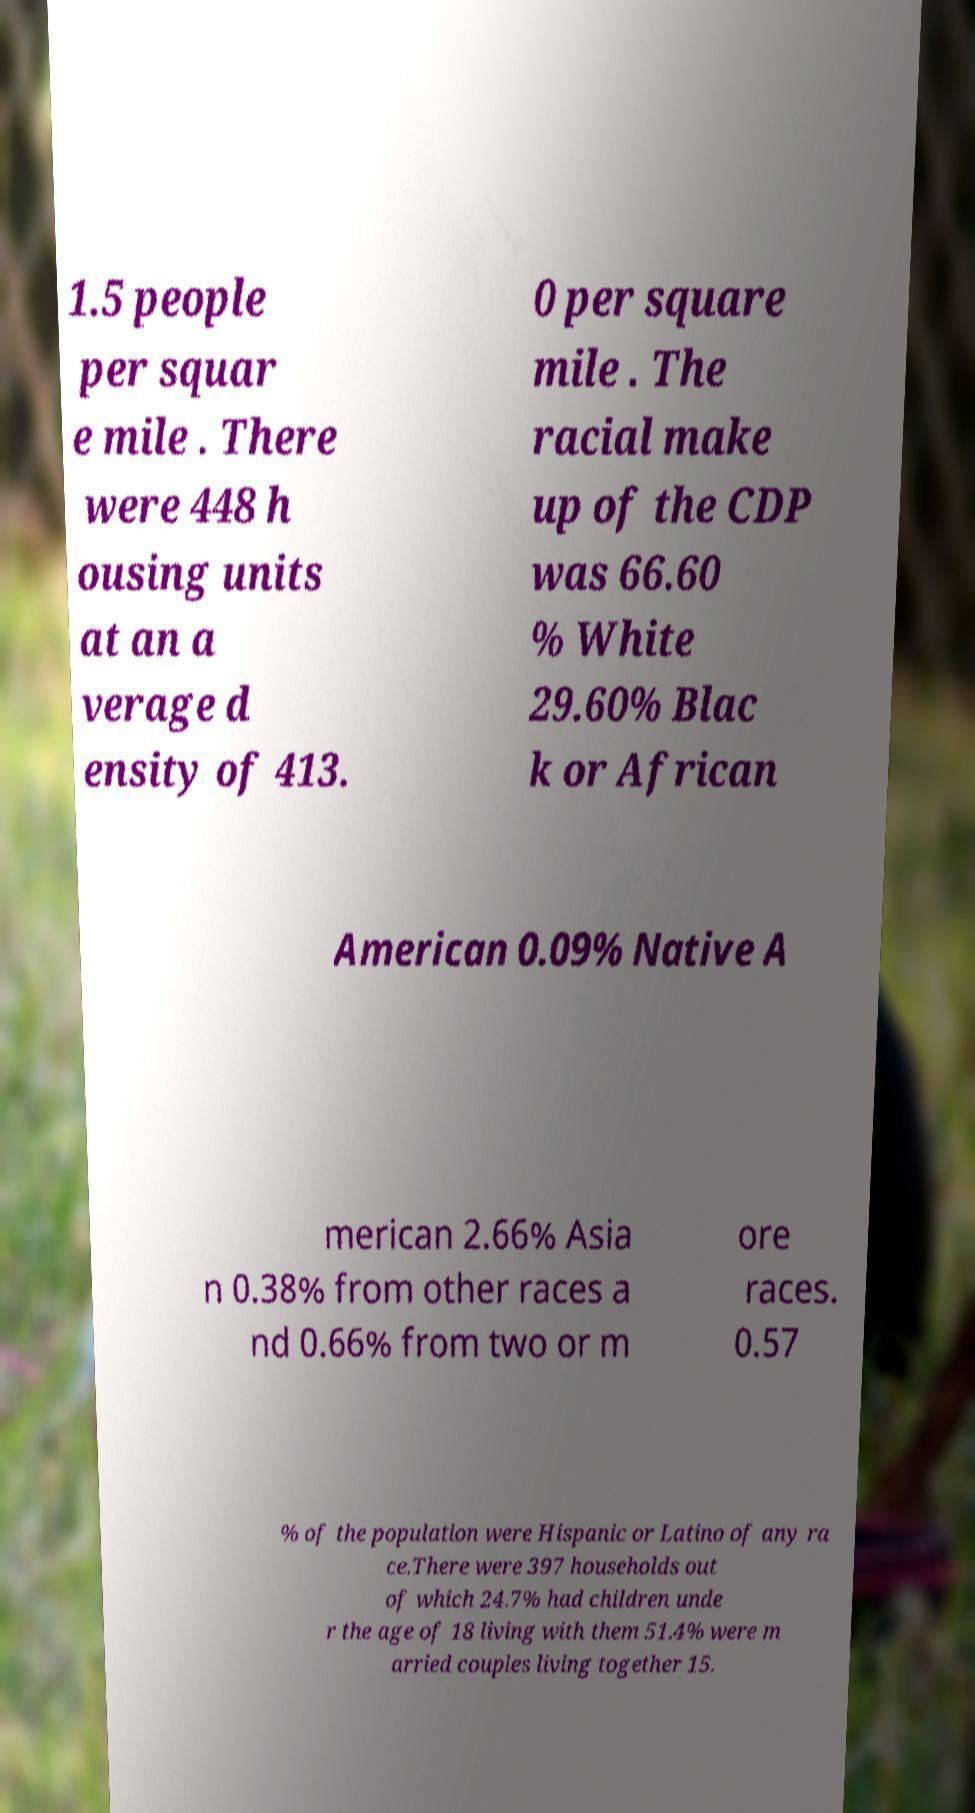Can you accurately transcribe the text from the provided image for me? 1.5 people per squar e mile . There were 448 h ousing units at an a verage d ensity of 413. 0 per square mile . The racial make up of the CDP was 66.60 % White 29.60% Blac k or African American 0.09% Native A merican 2.66% Asia n 0.38% from other races a nd 0.66% from two or m ore races. 0.57 % of the population were Hispanic or Latino of any ra ce.There were 397 households out of which 24.7% had children unde r the age of 18 living with them 51.4% were m arried couples living together 15. 